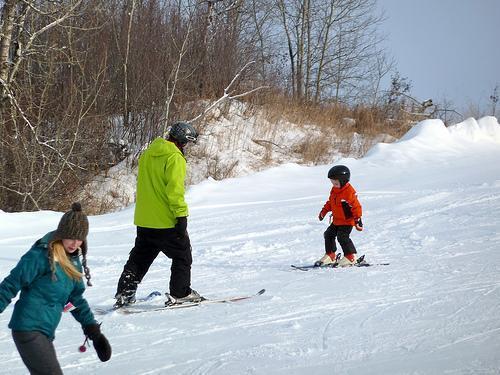How many ladies are in the photo?
Give a very brief answer. 1. 